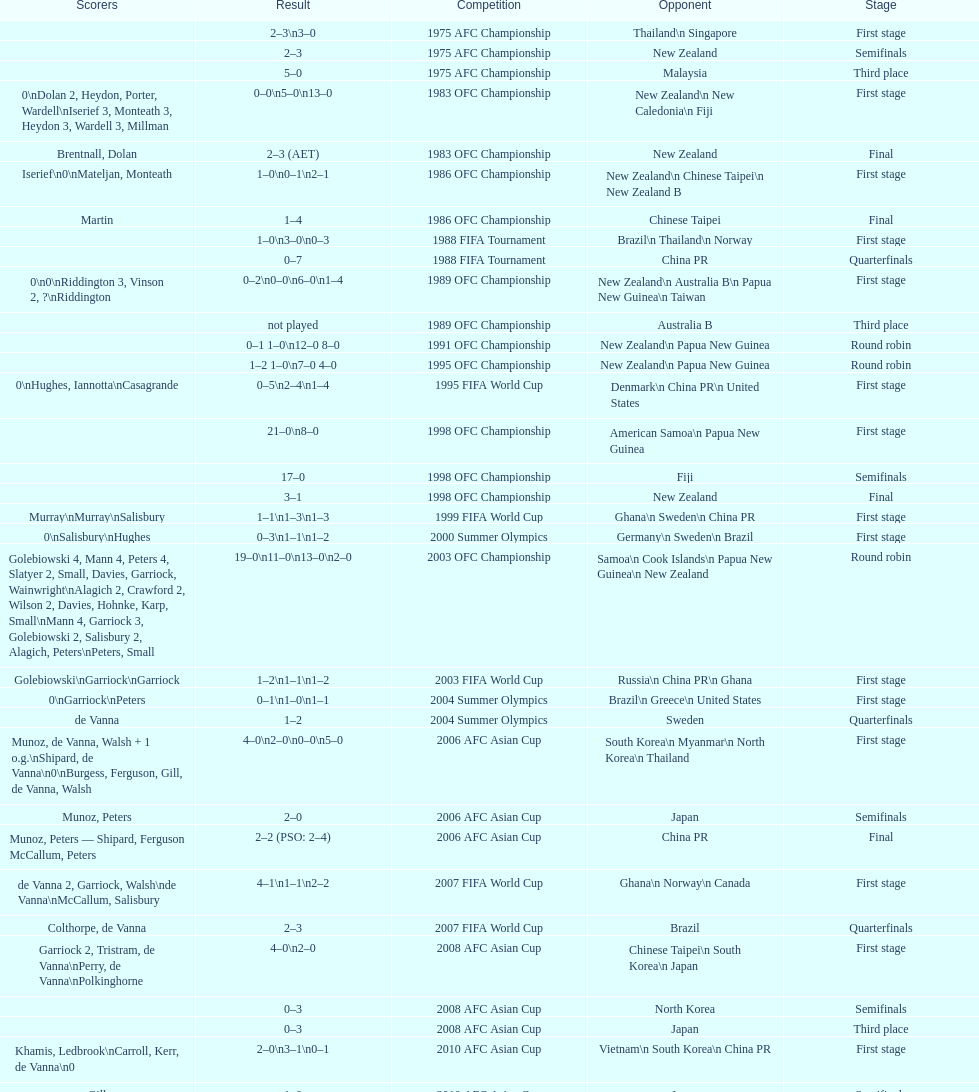How many players scored during the 1983 ofc championship competition? 9. 